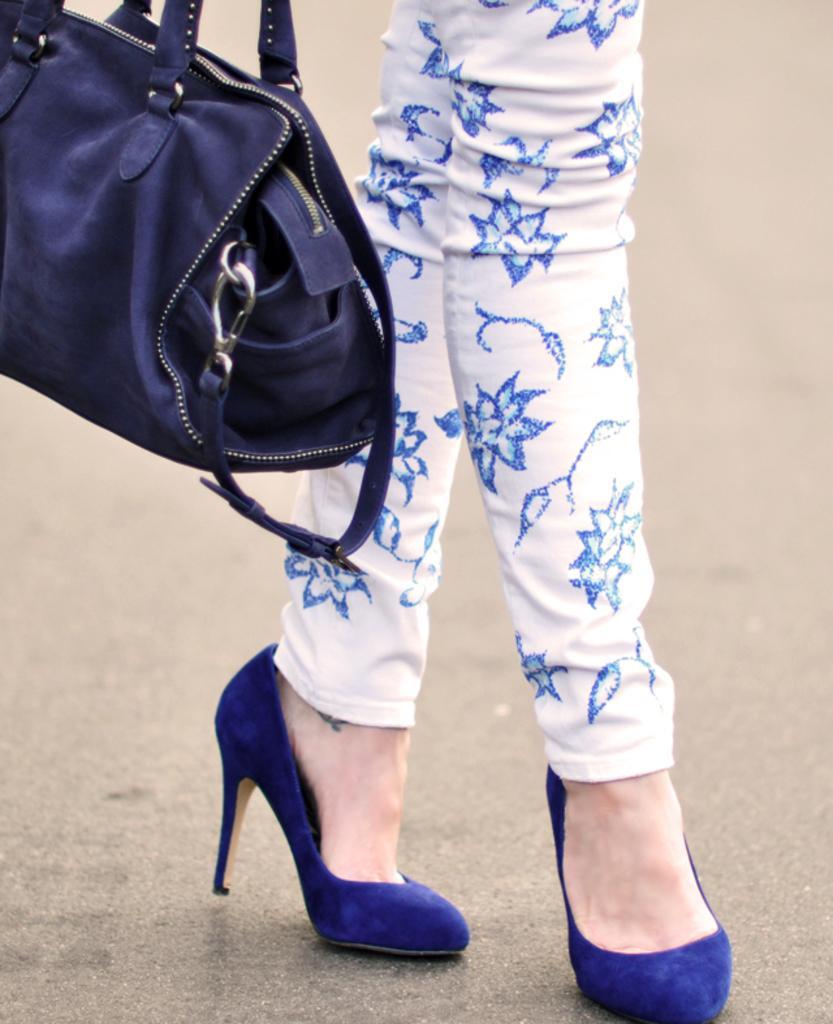Can you describe this image briefly? I can see a woman legs. she is wearing a white color trouser with blue color design on it. This is a blue colored handbag. These are blue colored heels. 